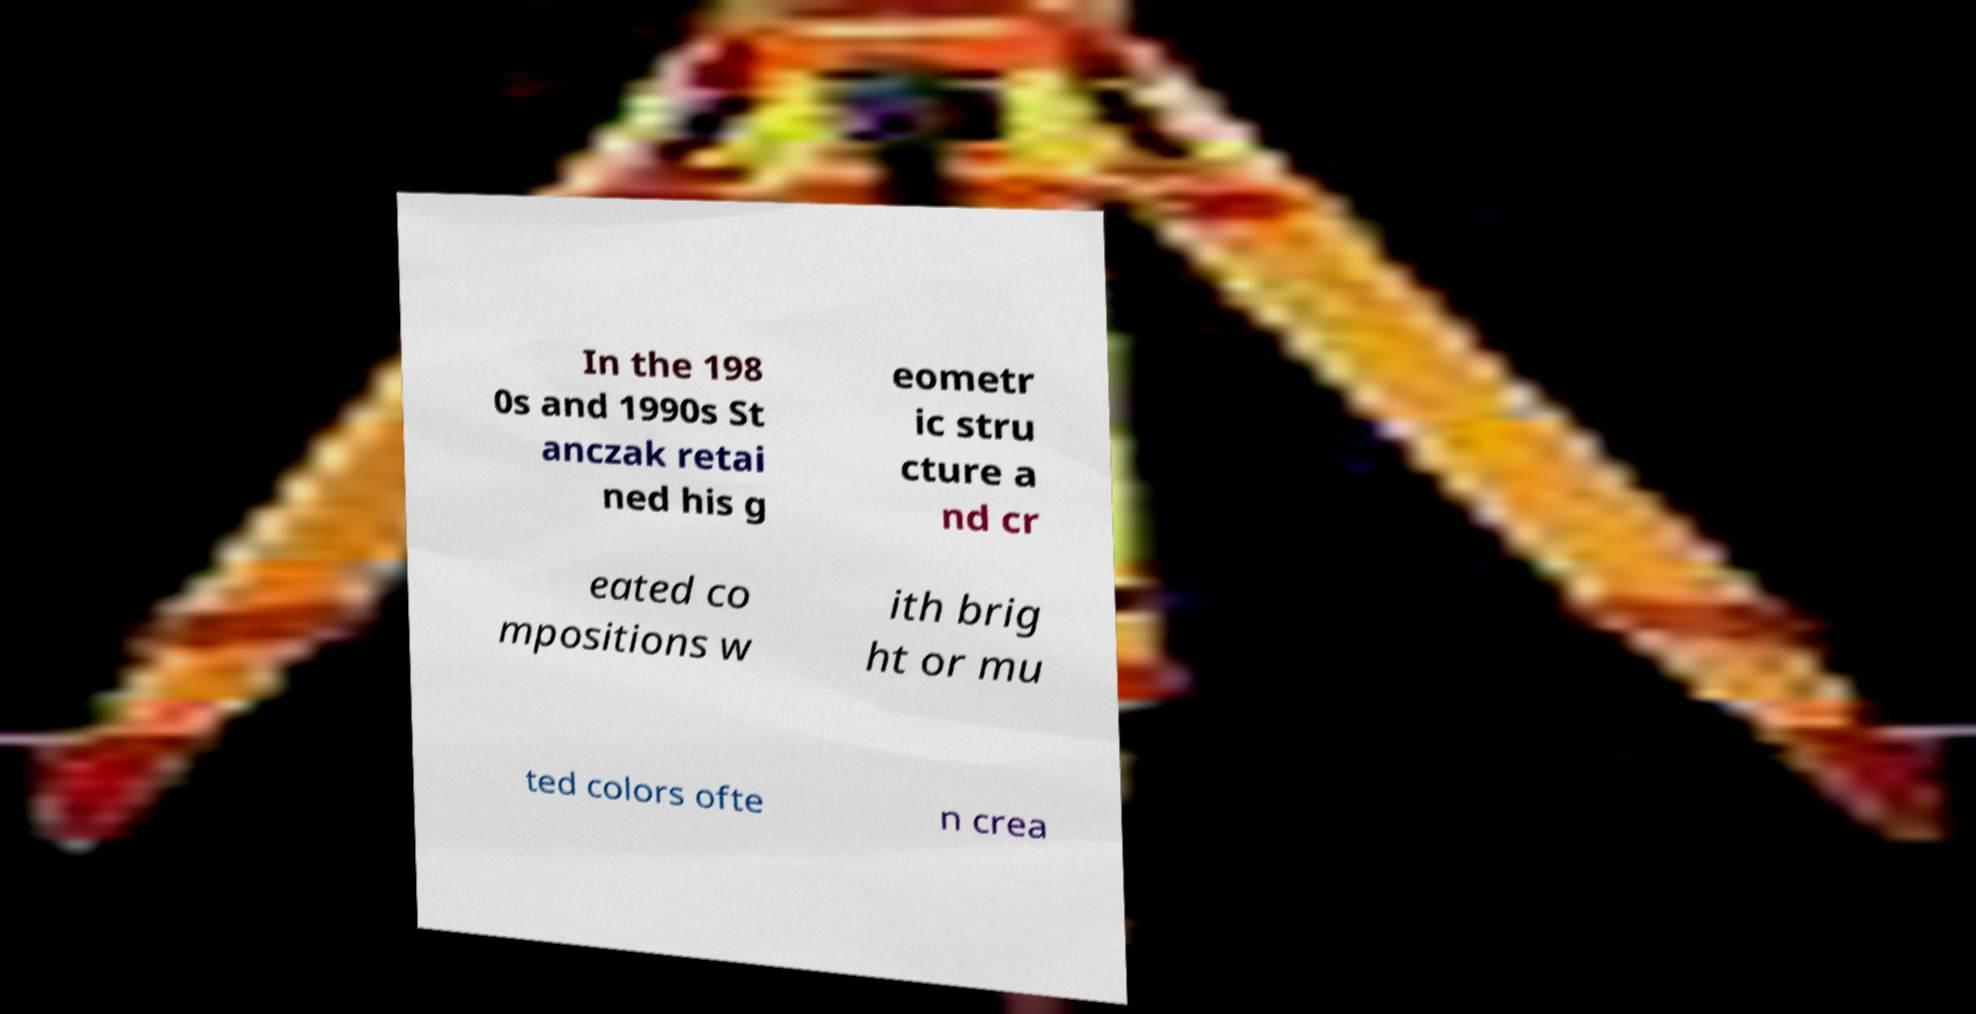Please read and relay the text visible in this image. What does it say? In the 198 0s and 1990s St anczak retai ned his g eometr ic stru cture a nd cr eated co mpositions w ith brig ht or mu ted colors ofte n crea 